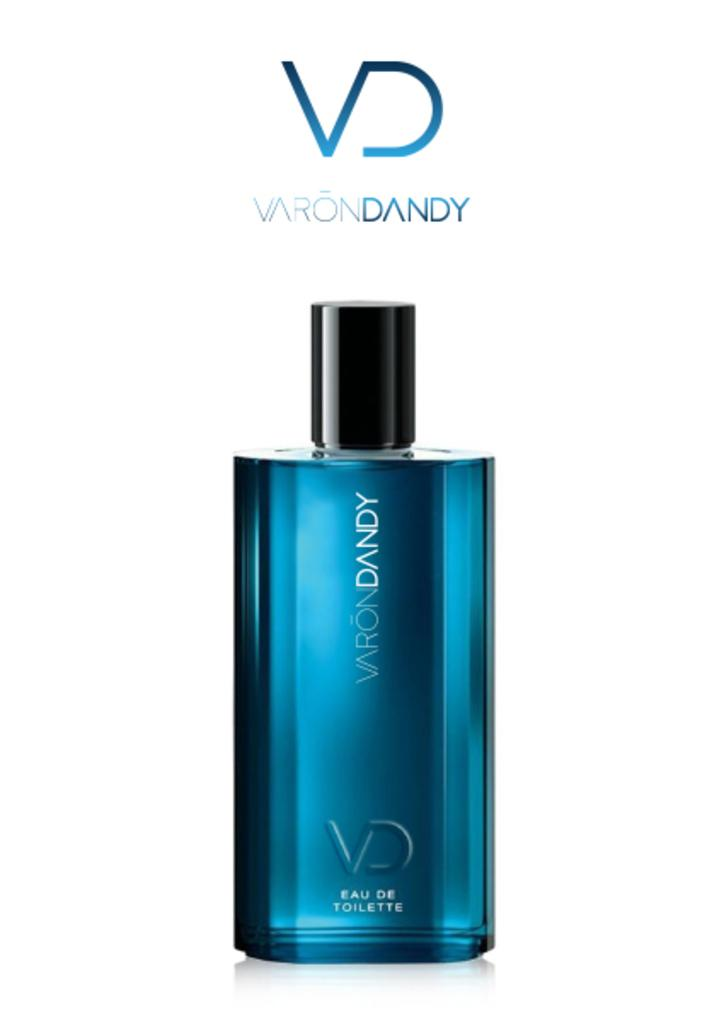<image>
Share a concise interpretation of the image provided. A bottle of VaronDandy is shown against a blank background. 